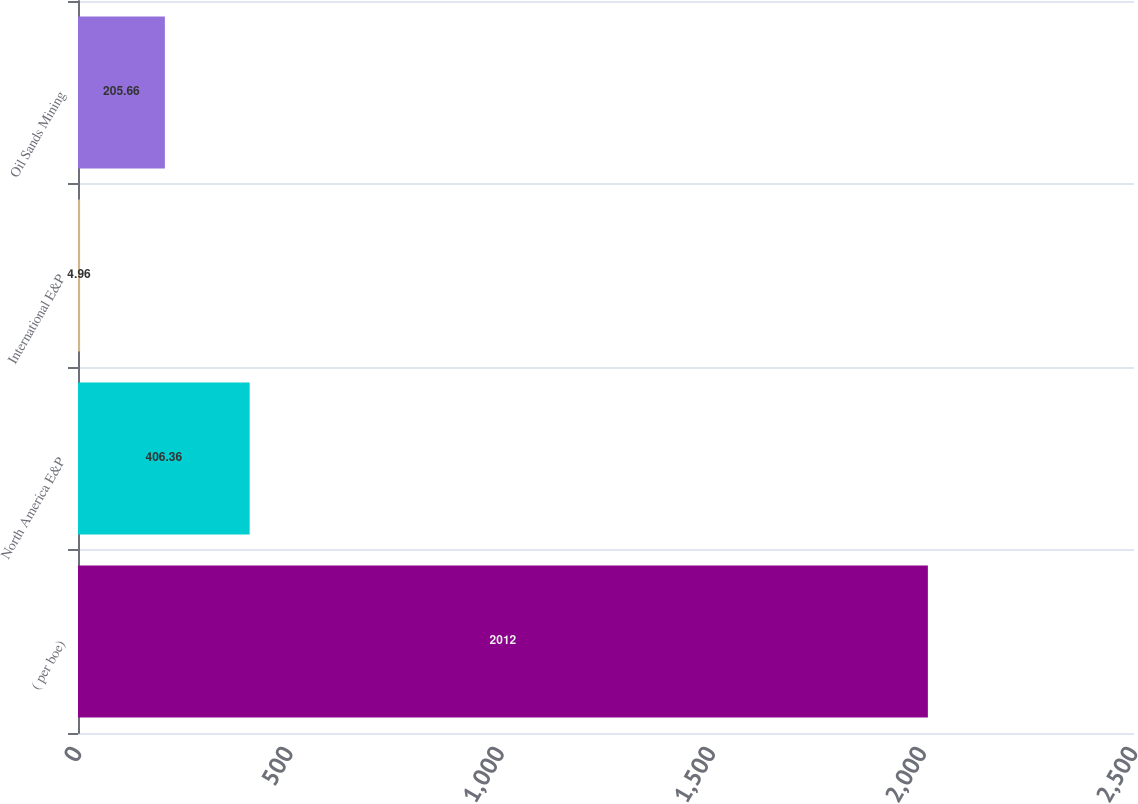Convert chart. <chart><loc_0><loc_0><loc_500><loc_500><bar_chart><fcel>( per boe)<fcel>North America E&P<fcel>International E&P<fcel>Oil Sands Mining<nl><fcel>2012<fcel>406.36<fcel>4.96<fcel>205.66<nl></chart> 